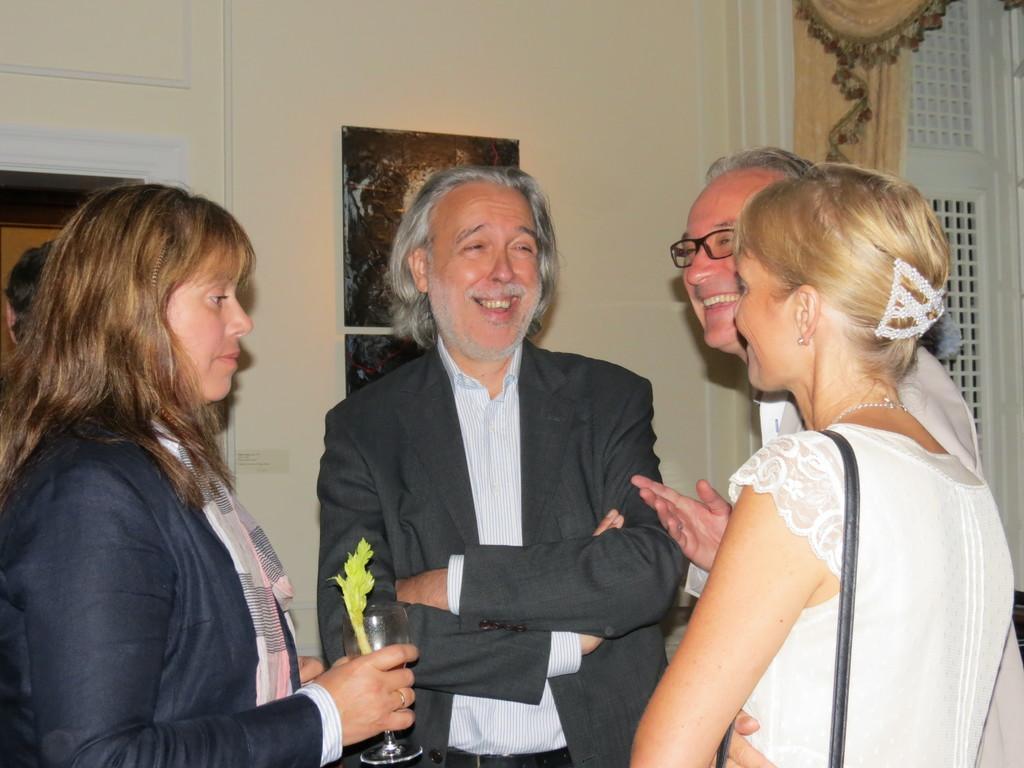Can you describe this image briefly? In the center of the image we can see persons standing on the floor. In the background we can see photo frames, door, curtain and windows. 